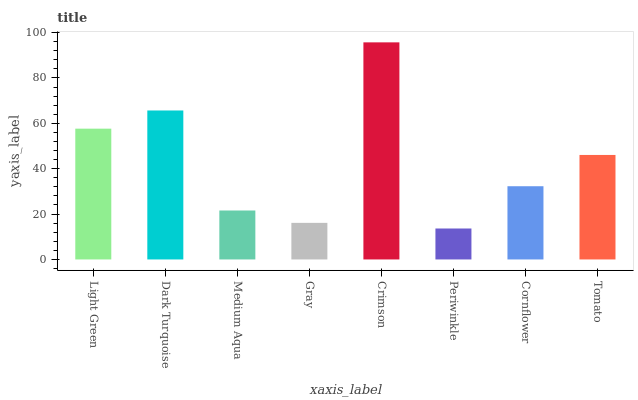Is Periwinkle the minimum?
Answer yes or no. Yes. Is Crimson the maximum?
Answer yes or no. Yes. Is Dark Turquoise the minimum?
Answer yes or no. No. Is Dark Turquoise the maximum?
Answer yes or no. No. Is Dark Turquoise greater than Light Green?
Answer yes or no. Yes. Is Light Green less than Dark Turquoise?
Answer yes or no. Yes. Is Light Green greater than Dark Turquoise?
Answer yes or no. No. Is Dark Turquoise less than Light Green?
Answer yes or no. No. Is Tomato the high median?
Answer yes or no. Yes. Is Cornflower the low median?
Answer yes or no. Yes. Is Light Green the high median?
Answer yes or no. No. Is Gray the low median?
Answer yes or no. No. 